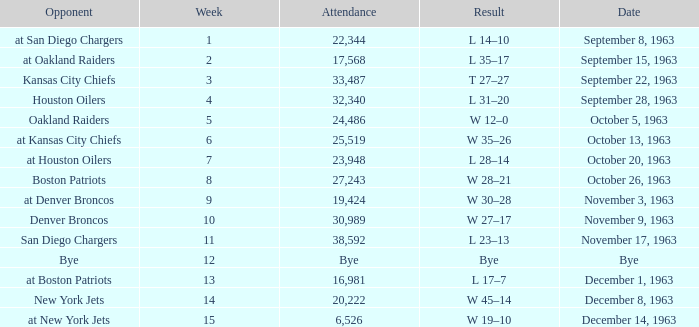Which Result has a Week smaller than 11, and Attendance of 17,568? L 35–17. Can you parse all the data within this table? {'header': ['Opponent', 'Week', 'Attendance', 'Result', 'Date'], 'rows': [['at San Diego Chargers', '1', '22,344', 'L 14–10', 'September 8, 1963'], ['at Oakland Raiders', '2', '17,568', 'L 35–17', 'September 15, 1963'], ['Kansas City Chiefs', '3', '33,487', 'T 27–27', 'September 22, 1963'], ['Houston Oilers', '4', '32,340', 'L 31–20', 'September 28, 1963'], ['Oakland Raiders', '5', '24,486', 'W 12–0', 'October 5, 1963'], ['at Kansas City Chiefs', '6', '25,519', 'W 35–26', 'October 13, 1963'], ['at Houston Oilers', '7', '23,948', 'L 28–14', 'October 20, 1963'], ['Boston Patriots', '8', '27,243', 'W 28–21', 'October 26, 1963'], ['at Denver Broncos', '9', '19,424', 'W 30–28', 'November 3, 1963'], ['Denver Broncos', '10', '30,989', 'W 27–17', 'November 9, 1963'], ['San Diego Chargers', '11', '38,592', 'L 23–13', 'November 17, 1963'], ['Bye', '12', 'Bye', 'Bye', 'Bye'], ['at Boston Patriots', '13', '16,981', 'L 17–7', 'December 1, 1963'], ['New York Jets', '14', '20,222', 'W 45–14', 'December 8, 1963'], ['at New York Jets', '15', '6,526', 'W 19–10', 'December 14, 1963']]} 